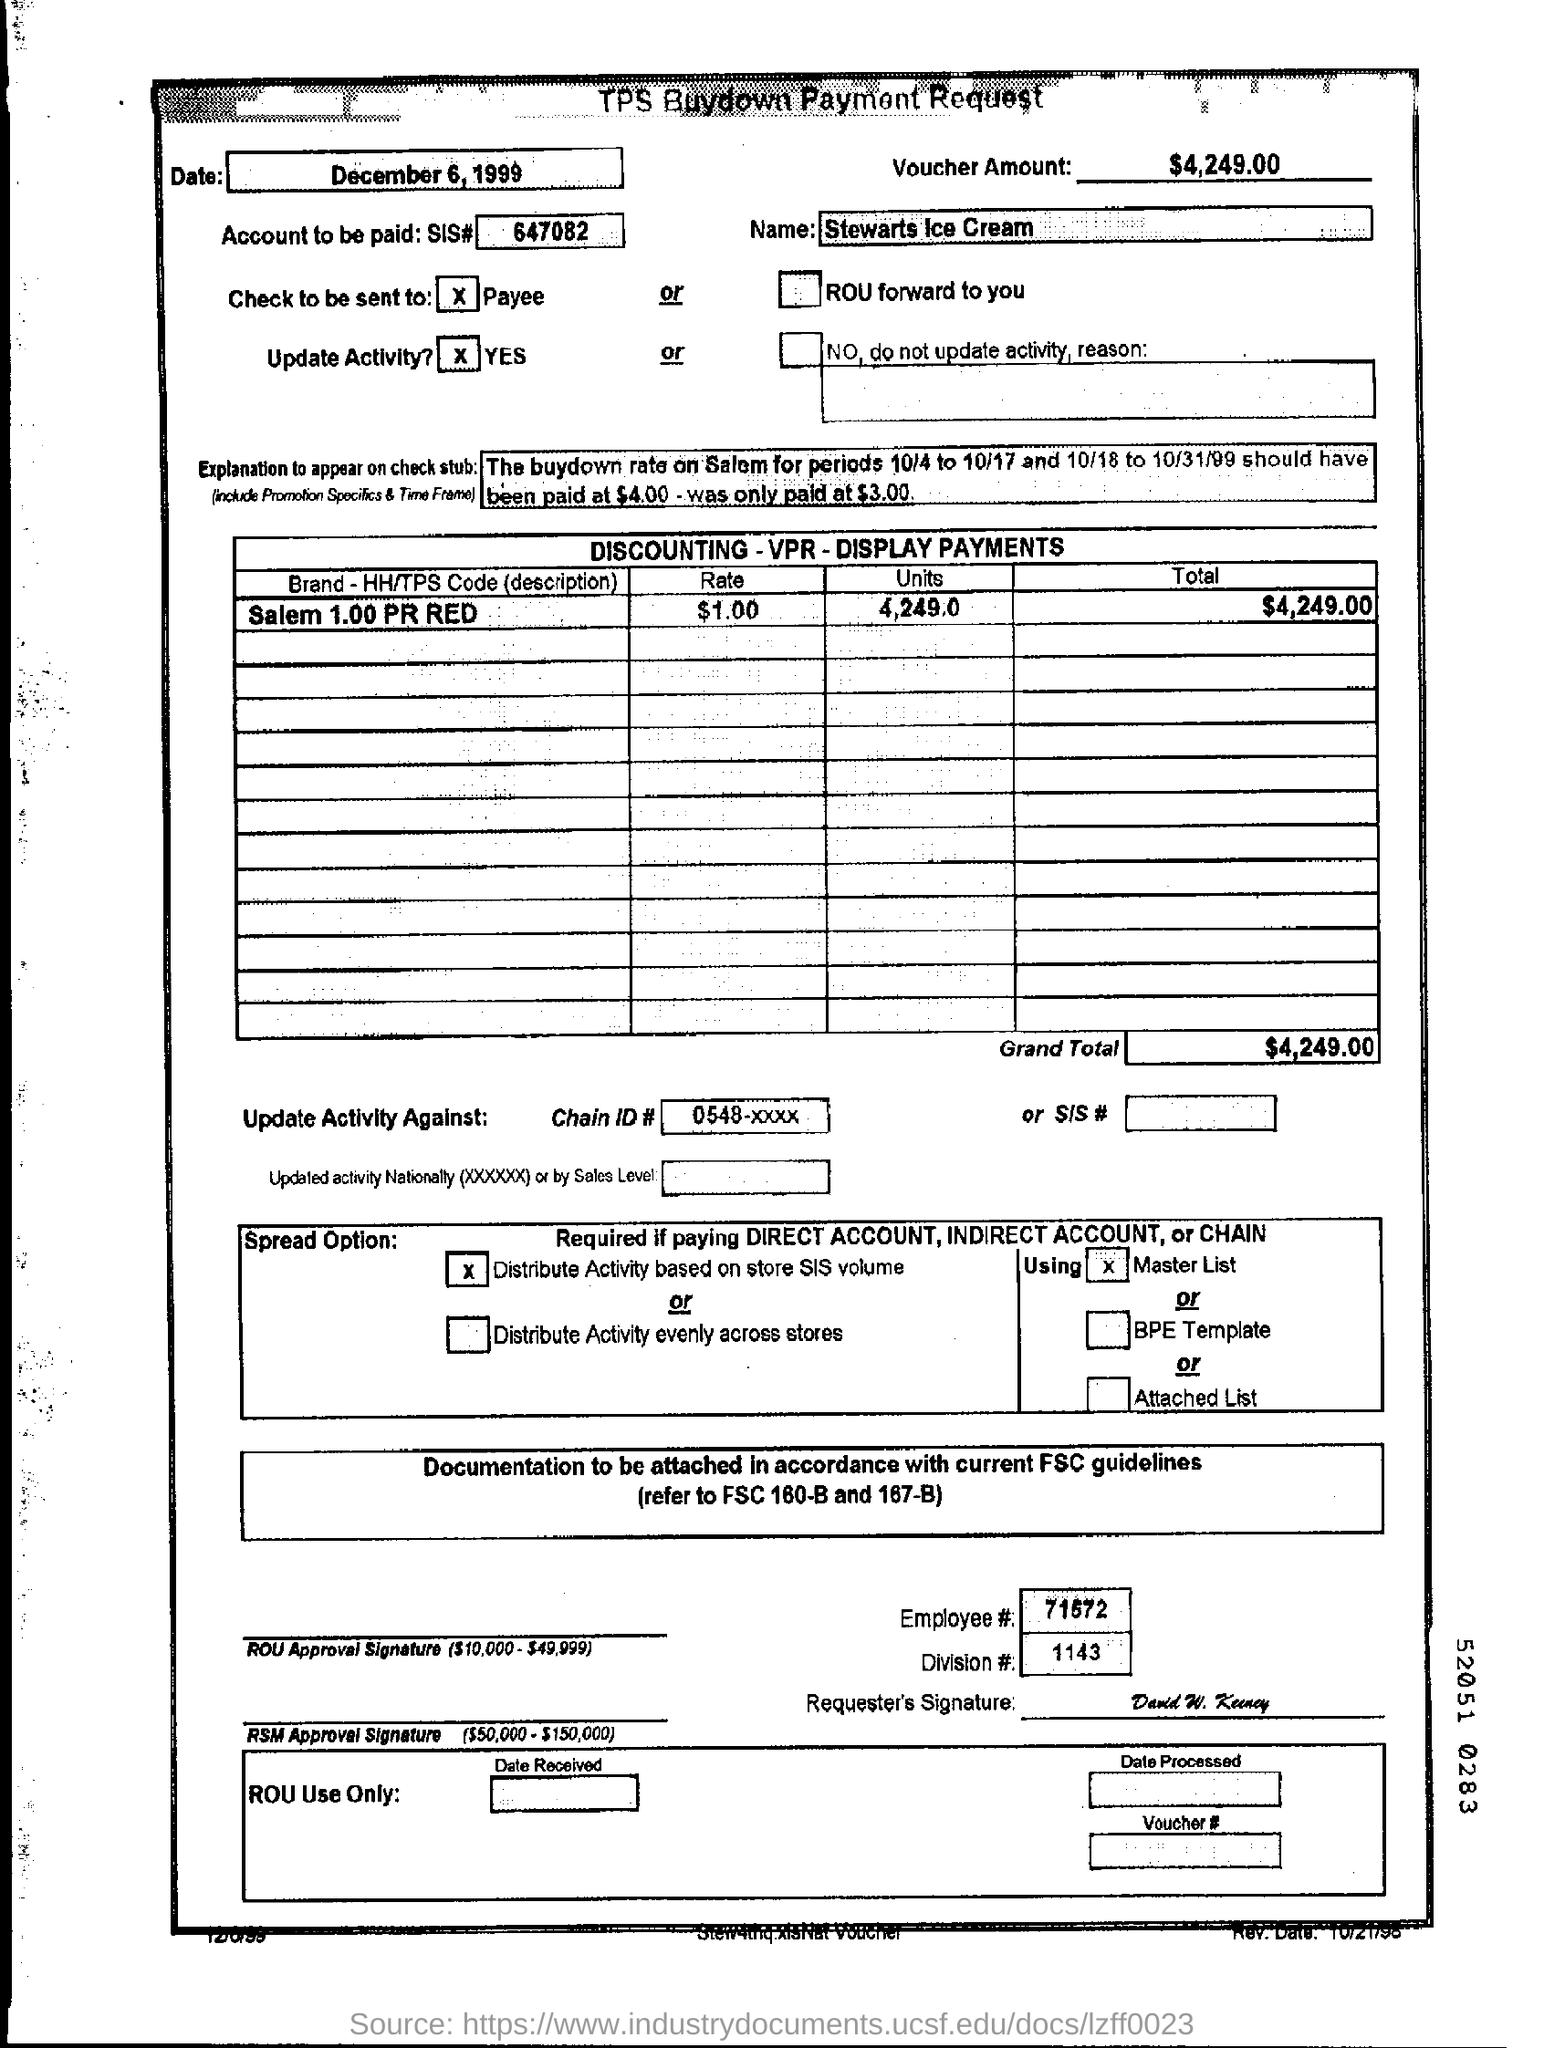What is the Voucher Amount?
Keep it short and to the point. $4,249.00. What is the date mentioned in the document?
Offer a very short reply. December 6, 1999. What is the Employee #  no?
Your response must be concise. 71572. 